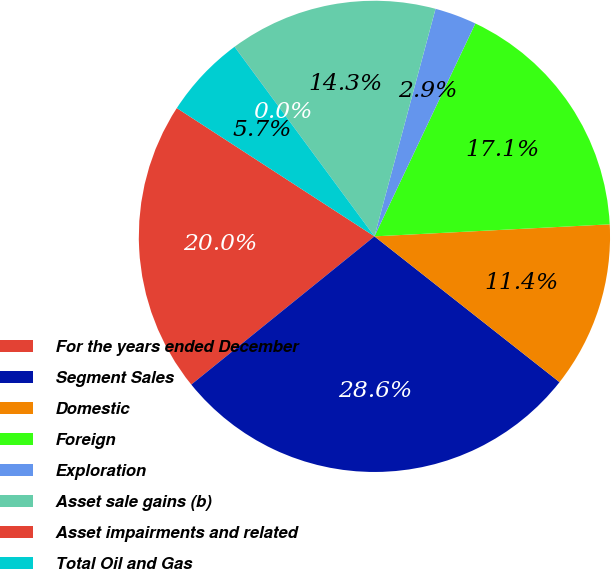Convert chart to OTSL. <chart><loc_0><loc_0><loc_500><loc_500><pie_chart><fcel>For the years ended December<fcel>Segment Sales<fcel>Domestic<fcel>Foreign<fcel>Exploration<fcel>Asset sale gains (b)<fcel>Asset impairments and related<fcel>Total Oil and Gas<nl><fcel>19.99%<fcel>28.55%<fcel>11.43%<fcel>17.14%<fcel>2.87%<fcel>14.28%<fcel>0.01%<fcel>5.72%<nl></chart> 